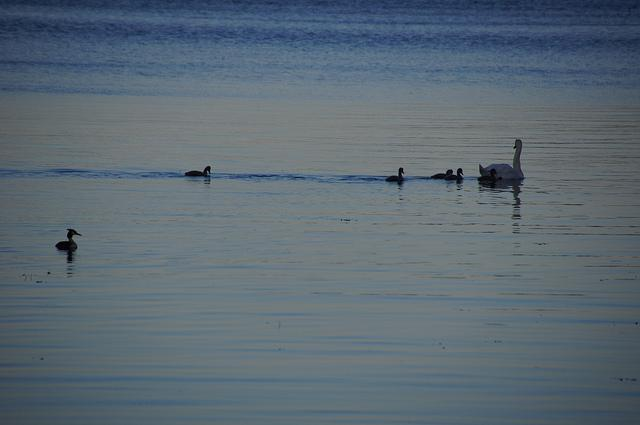What type of birds are the little ones? Please explain your reasoning. swan. The little birds are the big swan's children. 